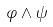Convert formula to latex. <formula><loc_0><loc_0><loc_500><loc_500>\varphi \wedge \psi</formula> 